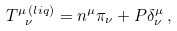Convert formula to latex. <formula><loc_0><loc_0><loc_500><loc_500>T ^ { \mu \, ( l i q ) } _ { \ \nu } = n ^ { \mu } \pi _ { \nu } + P \delta ^ { \mu } _ { \nu } \, ,</formula> 